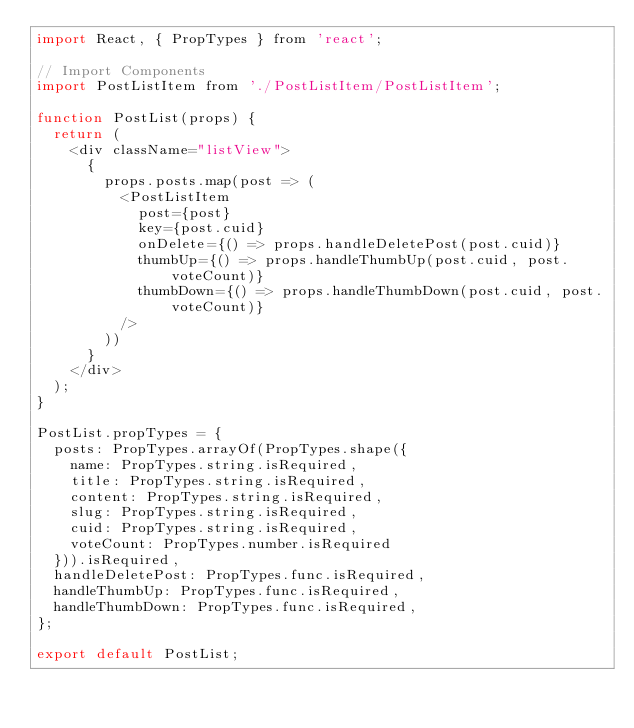<code> <loc_0><loc_0><loc_500><loc_500><_JavaScript_>import React, { PropTypes } from 'react';

// Import Components
import PostListItem from './PostListItem/PostListItem';

function PostList(props) {
  return (
    <div className="listView">
      {
        props.posts.map(post => (
          <PostListItem
            post={post}
            key={post.cuid}
            onDelete={() => props.handleDeletePost(post.cuid)}
            thumbUp={() => props.handleThumbUp(post.cuid, post.voteCount)}
            thumbDown={() => props.handleThumbDown(post.cuid, post.voteCount)}
          />
        ))
      }
    </div>
  );
}

PostList.propTypes = {
  posts: PropTypes.arrayOf(PropTypes.shape({
    name: PropTypes.string.isRequired,
    title: PropTypes.string.isRequired,
    content: PropTypes.string.isRequired,
    slug: PropTypes.string.isRequired,
    cuid: PropTypes.string.isRequired,
    voteCount: PropTypes.number.isRequired
  })).isRequired,
  handleDeletePost: PropTypes.func.isRequired,
  handleThumbUp: PropTypes.func.isRequired,
  handleThumbDown: PropTypes.func.isRequired,
};

export default PostList;
</code> 